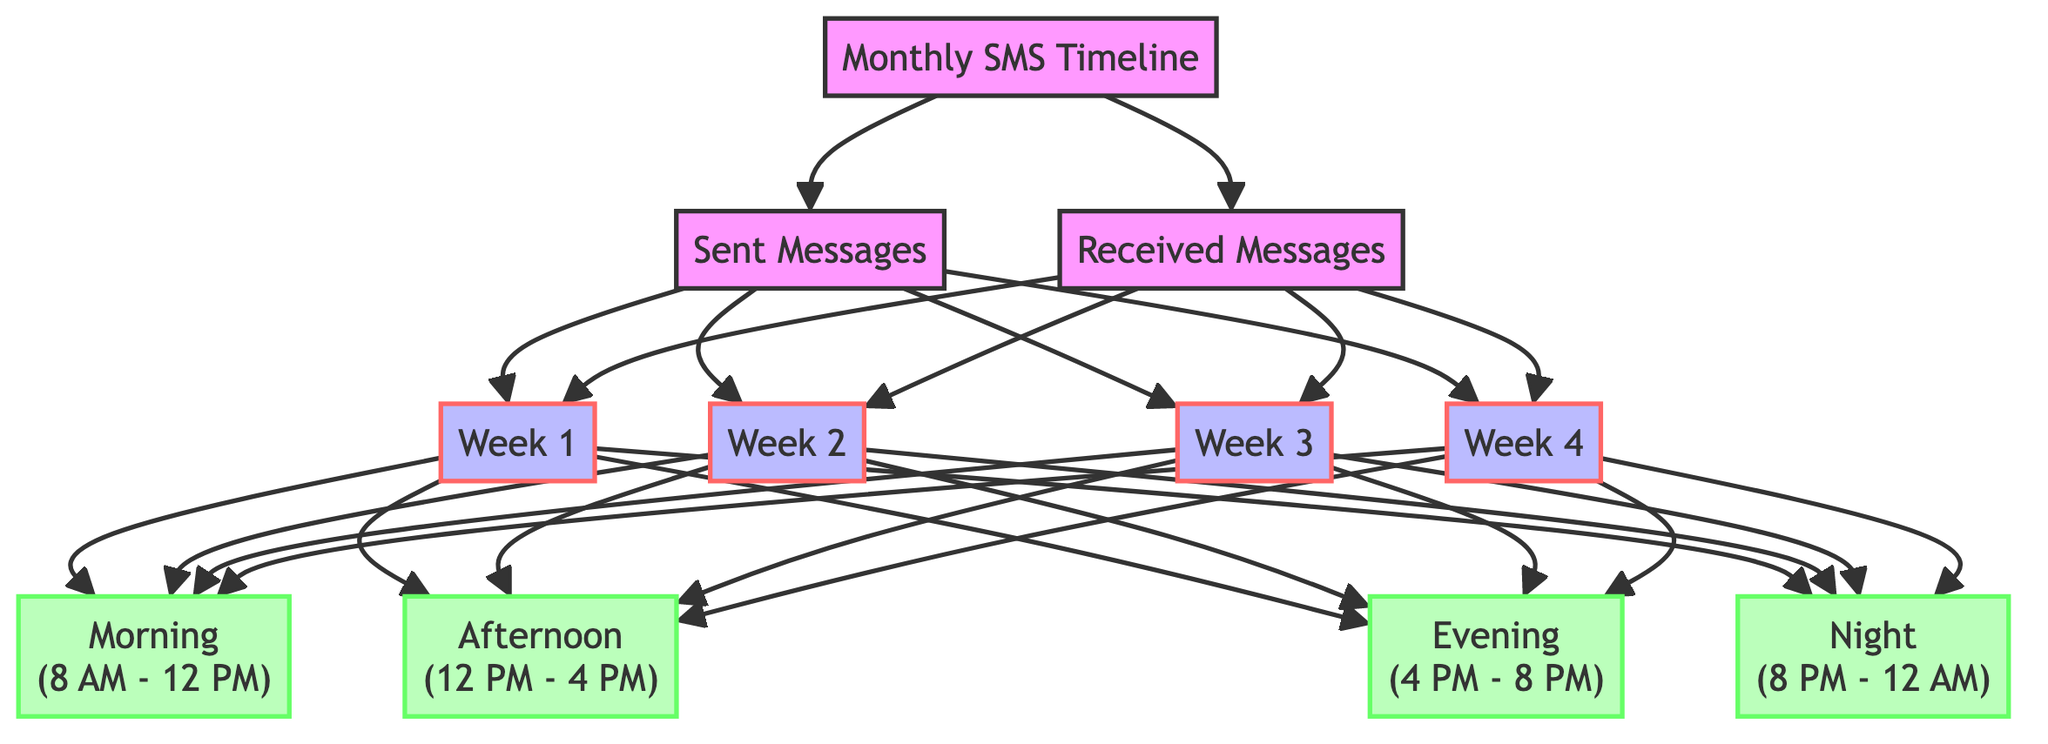What are the main categories represented in the diagram? The diagram represents two main categories: Sent Messages and Received Messages, which are depicted as separate nodes stemming from the Monthly SMS Timeline.
Answer: Sent Messages, Received Messages How many weeks are represented in the diagram? There are four weeks represented in the diagram: Week 1, Week 2, Week 3, and Week 4. These are displayed as nodes connected to the Sent and Received Messages.
Answer: 4 Which time segment has the same number of nodes for both sent and received messages? Each week has the same structure for time segments, with Morning, Afternoon, Evening, and Night segments displaying nodes for both sent and received messages. Therefore, all time segments share this characteristic.
Answer: All time segments What is the relationship between the Weeks and the Time Segments? Each week node (Week 1, Week 2, Week 3, Week 4) is connected to four time segment nodes (Morning, Afternoon, Evening, Night), indicating that for each week, messages are categorized by time.
Answer: Connected Which week likely had the highest SMS activity based on typical daily patterns? To determine which week had the highest SMS activity, we can infer that certain days typically have more messaging traffic, especially weekdays in the Morning and Evening segments. Without data specifics, it's logical to deduce that one of the mid-month weeks (Week 2 or Week 3) would likely have peak activity.
Answer: Week 2 or Week 3 What color signifies the week nodes in the diagram? The week nodes are represented with a blue fill (#bbf), as specified by the class definition in the code.
Answer: Blue How many time segments are divided for each week? Each week is divided into four time segments: Morning, Afternoon, Evening, and Night, allowing for a detailed breakdown of SMS activity throughout the day.
Answer: 4 Which piece of information is essential to identify peak messaging periods? The combination of weeks and time segments is essential to identify peak messaging periods, as it allows analysis of the number of messages sent and received throughout different times of the day across the month.
Answer: Weeks and Time Segments 